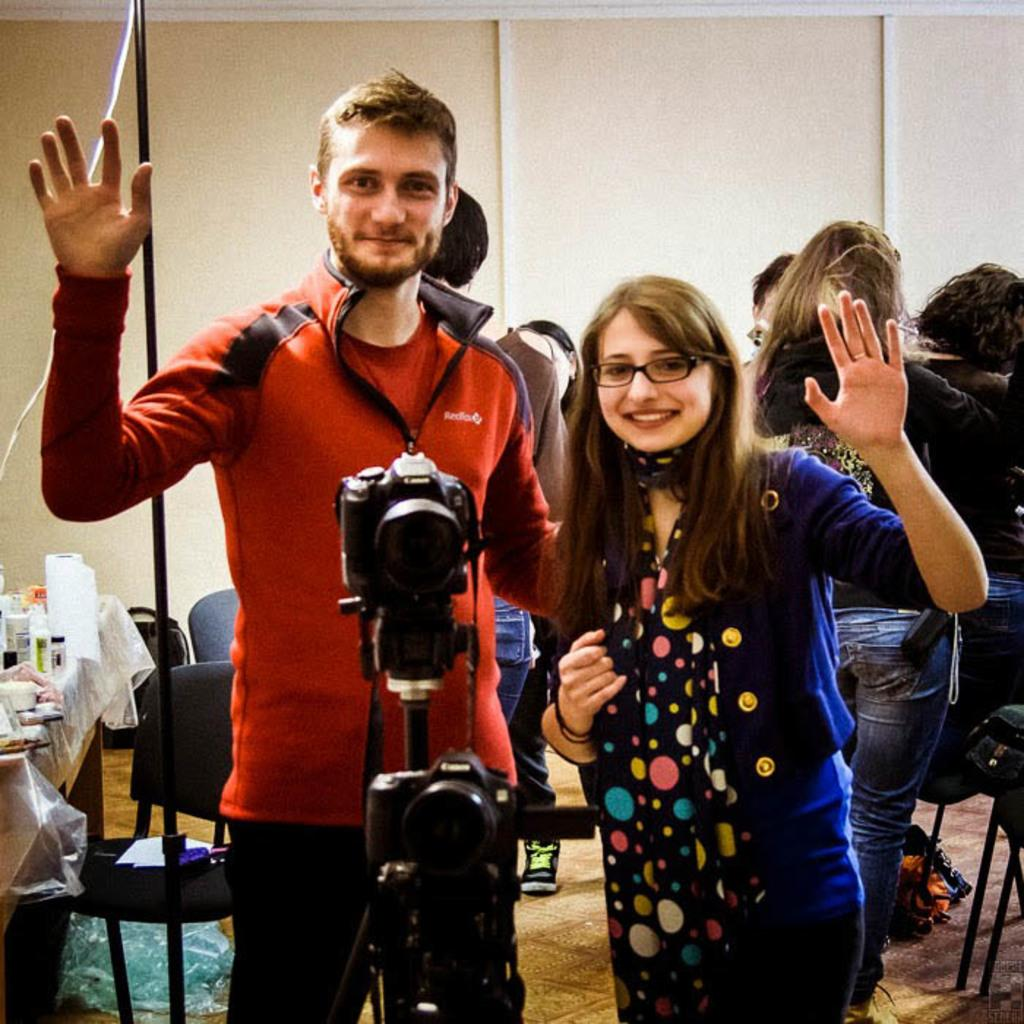Who or what is present in the image? There are people in the image. What object is visible in the image that is commonly used for capturing images? There is a camera in the image. What type of furniture is present in the image? There are chairs in the image. What can be seen on the table in the image? There are objects on a table in the image. What is the name of the library in the image? There is no library present in the image, so it is not possible to determine the name of a library. 